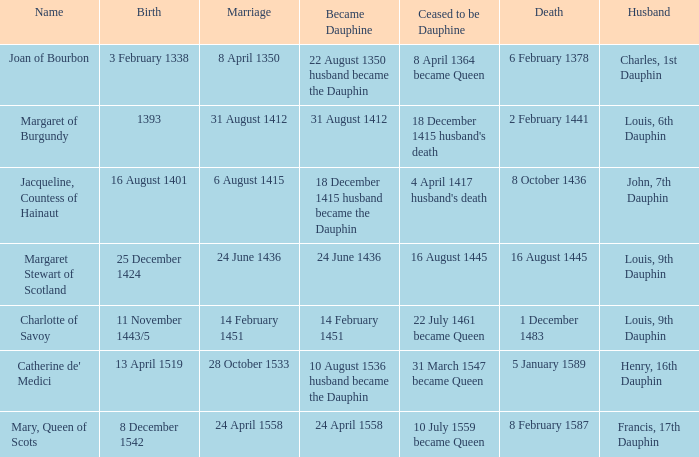When did the individual pass away if they were born on december 8, 1542? 8 February 1587. 